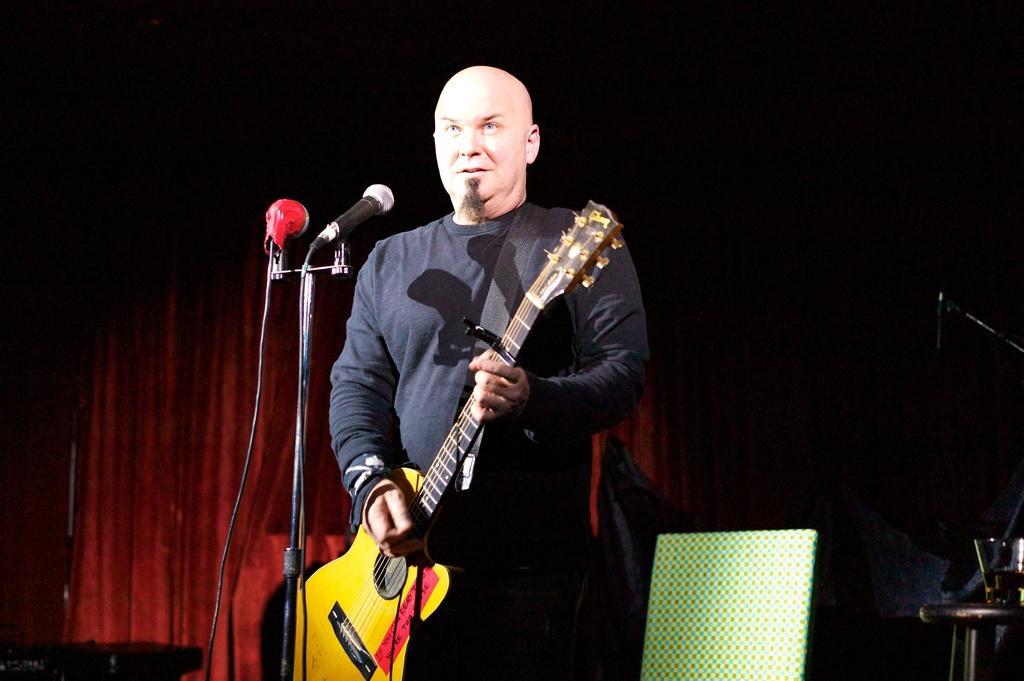Please provide a concise description of this image. The given picture shows a man holding a guitar and playing it. In front of him there are two microphones and a stand here. In the background, there is a chair and a red color curtain here. 